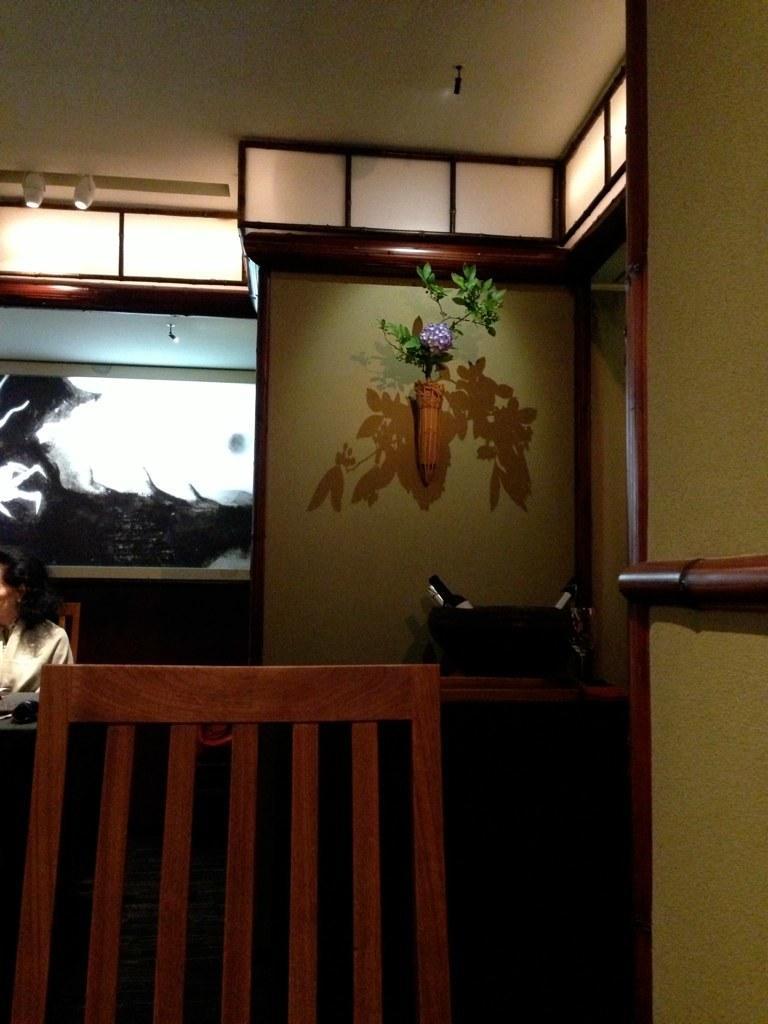How would you summarize this image in a sentence or two? In this picture we can see an inside view of a room, there is a chair in the front, in the background we can see a plant, on the left side there is a person sitting on the chair, we can see the ceiling at the top of the picture. 